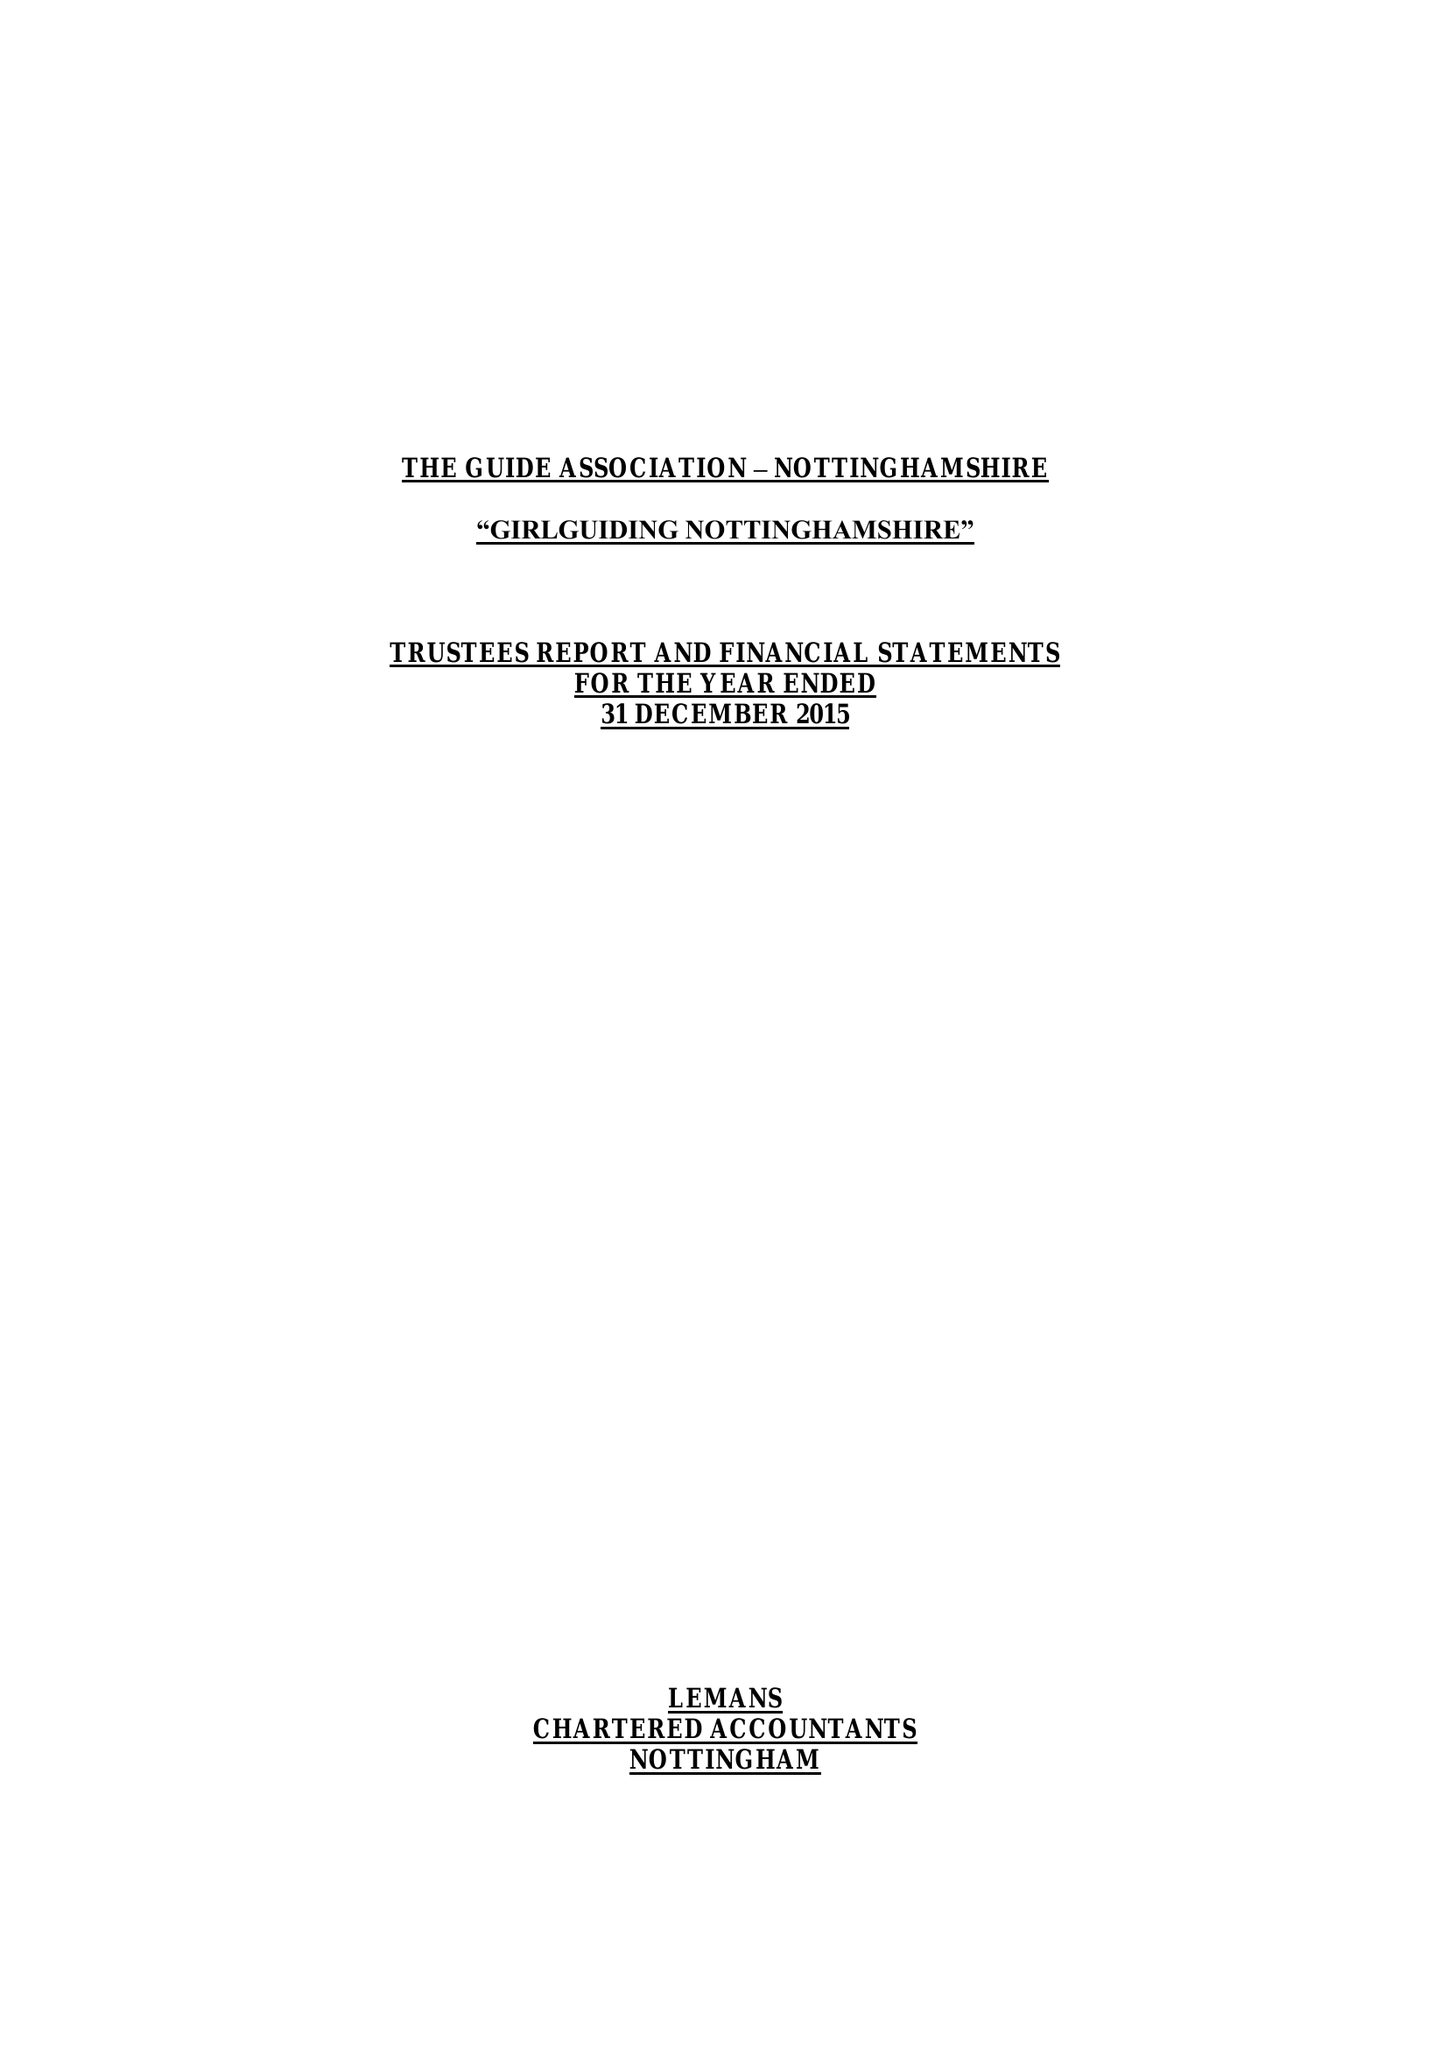What is the value for the address__postcode?
Answer the question using a single word or phrase. NG4 3DF 